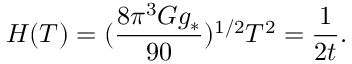Convert formula to latex. <formula><loc_0><loc_0><loc_500><loc_500>H ( T ) = ( { \frac { 8 \pi ^ { 3 } G g _ { * } } { 9 0 } } ) ^ { 1 / 2 } T ^ { 2 } = { \frac { 1 } { 2 t } } .</formula> 